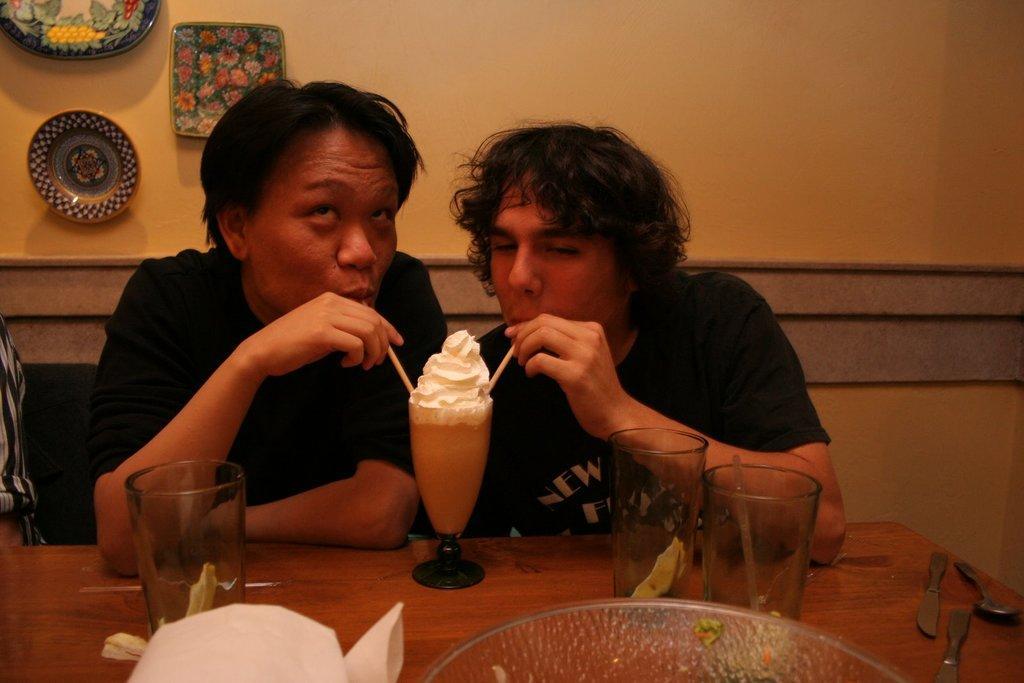Can you describe this image briefly? In this image there are two persons sitting and holding the straws in the glass, there are tissues, bowl, spoon, knives,glasses on the table , and in the background there are ceramic plates attached to the wall. 